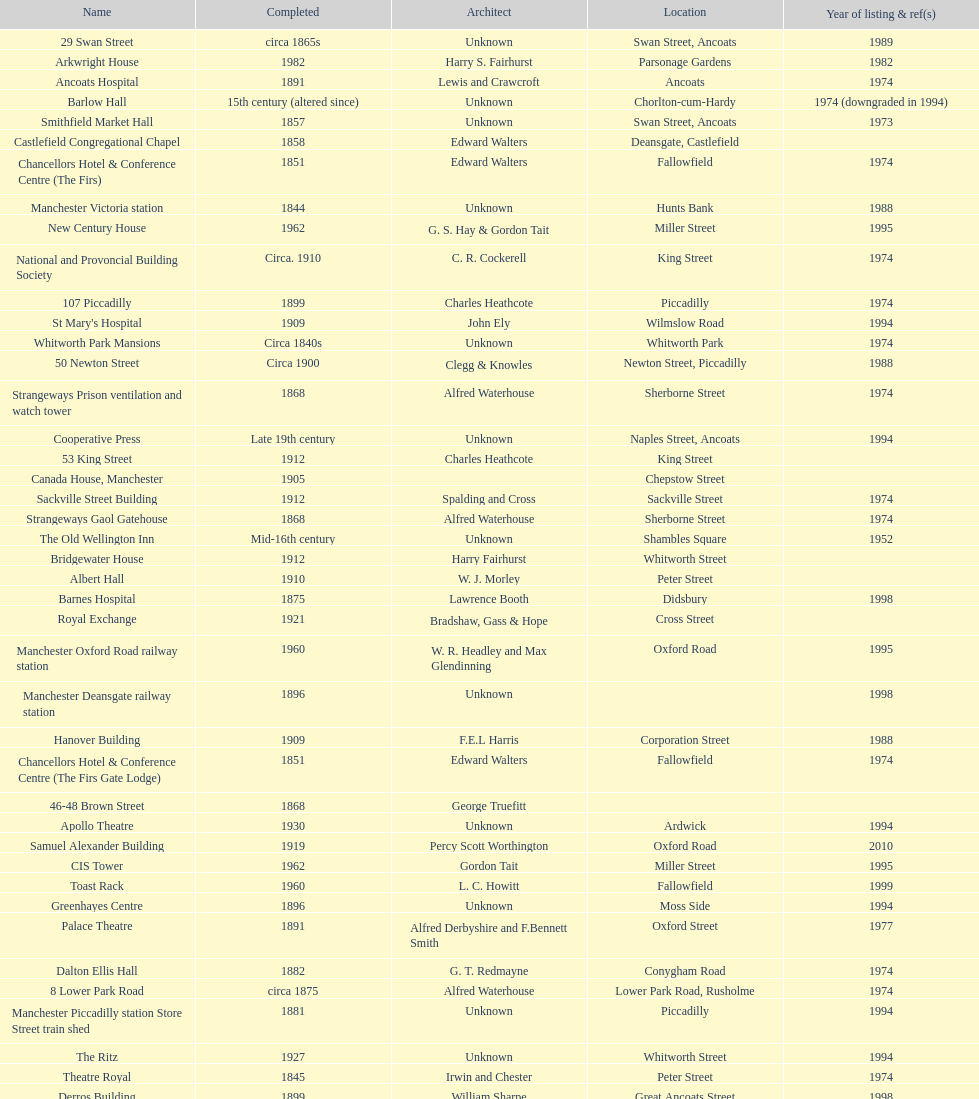What is the difference, in years, between the completion dates of 53 king street and castlefield congregational chapel? 54 years. Could you parse the entire table? {'header': ['Name', 'Completed', 'Architect', 'Location', 'Year of listing & ref(s)'], 'rows': [['29 Swan Street', 'circa 1865s', 'Unknown', 'Swan Street, Ancoats', '1989'], ['Arkwright House', '1982', 'Harry S. Fairhurst', 'Parsonage Gardens', '1982'], ['Ancoats Hospital', '1891', 'Lewis and Crawcroft', 'Ancoats', '1974'], ['Barlow Hall', '15th century (altered since)', 'Unknown', 'Chorlton-cum-Hardy', '1974 (downgraded in 1994)'], ['Smithfield Market Hall', '1857', 'Unknown', 'Swan Street, Ancoats', '1973'], ['Castlefield Congregational Chapel', '1858', 'Edward Walters', 'Deansgate, Castlefield', ''], ['Chancellors Hotel & Conference Centre (The Firs)', '1851', 'Edward Walters', 'Fallowfield', '1974'], ['Manchester Victoria station', '1844', 'Unknown', 'Hunts Bank', '1988'], ['New Century House', '1962', 'G. S. Hay & Gordon Tait', 'Miller Street', '1995'], ['National and Provoncial Building Society', 'Circa. 1910', 'C. R. Cockerell', 'King Street', '1974'], ['107 Piccadilly', '1899', 'Charles Heathcote', 'Piccadilly', '1974'], ["St Mary's Hospital", '1909', 'John Ely', 'Wilmslow Road', '1994'], ['Whitworth Park Mansions', 'Circa 1840s', 'Unknown', 'Whitworth Park', '1974'], ['50 Newton Street', 'Circa 1900', 'Clegg & Knowles', 'Newton Street, Piccadilly', '1988'], ['Strangeways Prison ventilation and watch tower', '1868', 'Alfred Waterhouse', 'Sherborne Street', '1974'], ['Cooperative Press', 'Late 19th century', 'Unknown', 'Naples Street, Ancoats', '1994'], ['53 King Street', '1912', 'Charles Heathcote', 'King Street', ''], ['Canada House, Manchester', '1905', '', 'Chepstow Street', ''], ['Sackville Street Building', '1912', 'Spalding and Cross', 'Sackville Street', '1974'], ['Strangeways Gaol Gatehouse', '1868', 'Alfred Waterhouse', 'Sherborne Street', '1974'], ['The Old Wellington Inn', 'Mid-16th century', 'Unknown', 'Shambles Square', '1952'], ['Bridgewater House', '1912', 'Harry Fairhurst', 'Whitworth Street', ''], ['Albert Hall', '1910', 'W. J. Morley', 'Peter Street', ''], ['Barnes Hospital', '1875', 'Lawrence Booth', 'Didsbury', '1998'], ['Royal Exchange', '1921', 'Bradshaw, Gass & Hope', 'Cross Street', ''], ['Manchester Oxford Road railway station', '1960', 'W. R. Headley and Max Glendinning', 'Oxford Road', '1995'], ['Manchester Deansgate railway station', '1896', 'Unknown', '', '1998'], ['Hanover Building', '1909', 'F.E.L Harris', 'Corporation Street', '1988'], ['Chancellors Hotel & Conference Centre (The Firs Gate Lodge)', '1851', 'Edward Walters', 'Fallowfield', '1974'], ['46-48 Brown Street', '1868', 'George Truefitt', '', ''], ['Apollo Theatre', '1930', 'Unknown', 'Ardwick', '1994'], ['Samuel Alexander Building', '1919', 'Percy Scott Worthington', 'Oxford Road', '2010'], ['CIS Tower', '1962', 'Gordon Tait', 'Miller Street', '1995'], ['Toast Rack', '1960', 'L. C. Howitt', 'Fallowfield', '1999'], ['Greenhayes Centre', '1896', 'Unknown', 'Moss Side', '1994'], ['Palace Theatre', '1891', 'Alfred Derbyshire and F.Bennett Smith', 'Oxford Street', '1977'], ['Dalton Ellis Hall', '1882', 'G. T. Redmayne', 'Conygham Road', '1974'], ['8 Lower Park Road', 'circa 1875', 'Alfred Waterhouse', 'Lower Park Road, Rusholme', '1974'], ['Manchester Piccadilly station Store Street train shed', '1881', 'Unknown', 'Piccadilly', '1994'], ['The Ritz', '1927', 'Unknown', 'Whitworth Street', '1994'], ['Theatre Royal', '1845', 'Irwin and Chester', 'Peter Street', '1974'], ['Derros Building', '1899', 'William Sharpe', 'Great Ancoats Street', '1998'], ['1 Booth Street', 'Circa 1850s', 'Unknown', 'Booth Street', '1974'], ['Corn Exchange', '1903', 'Unknown', 'Exchange Square', '1973'], ['St. James Buildings', '1912', 'Clegg, Fryer & Penman', '65-95 Oxford Street', '1988'], ['Ship Canal House', '1927', 'Harry S. Fairhurst', 'King Street', '1982'], ['Redfern Building', '1936', 'W. A. Johnson and J. W. Cooper', 'Dantzic Street', '1994'], ['Manchester Opera House', '1912', 'Richardson and Gill with Farquarson', 'Quay Street', '1974'], ['Holyoake House', '1911', 'F.E.L Harris', 'Dantzic Street', '1988'], ['235-291 Deansgate', '1899', 'Unknown', 'Deansgate', '1988']]} 